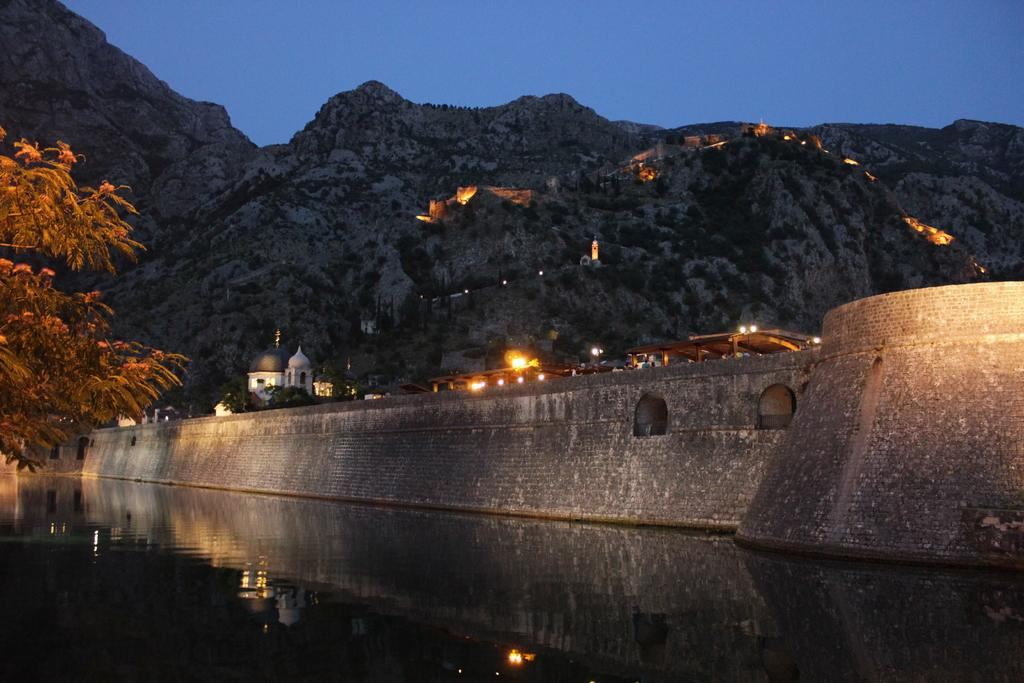What can be seen in the foreground of the image? There is water in the foreground of the image. What is located on the left side of the image? There is a tree on the left side of the image. What structures are visible in the background of the image? There is a bridge, buildings, and lights in the background of the image. What type of natural feature is visible in the background of the image? There are mountains in the background of the image. What else can be seen in the background of the image? The sky is visible in the background of the image. Can you tell me how many robin eggs are in the tree in the image? There are no robin eggs or robins mentioned in the image; it only features a tree, water, a bridge, buildings, lights, mountains, and the sky. What type of tomatoes are growing on the bridge in the image? There are no tomatoes or plants growing on the bridge in the image; it is a structure for crossing the water. 